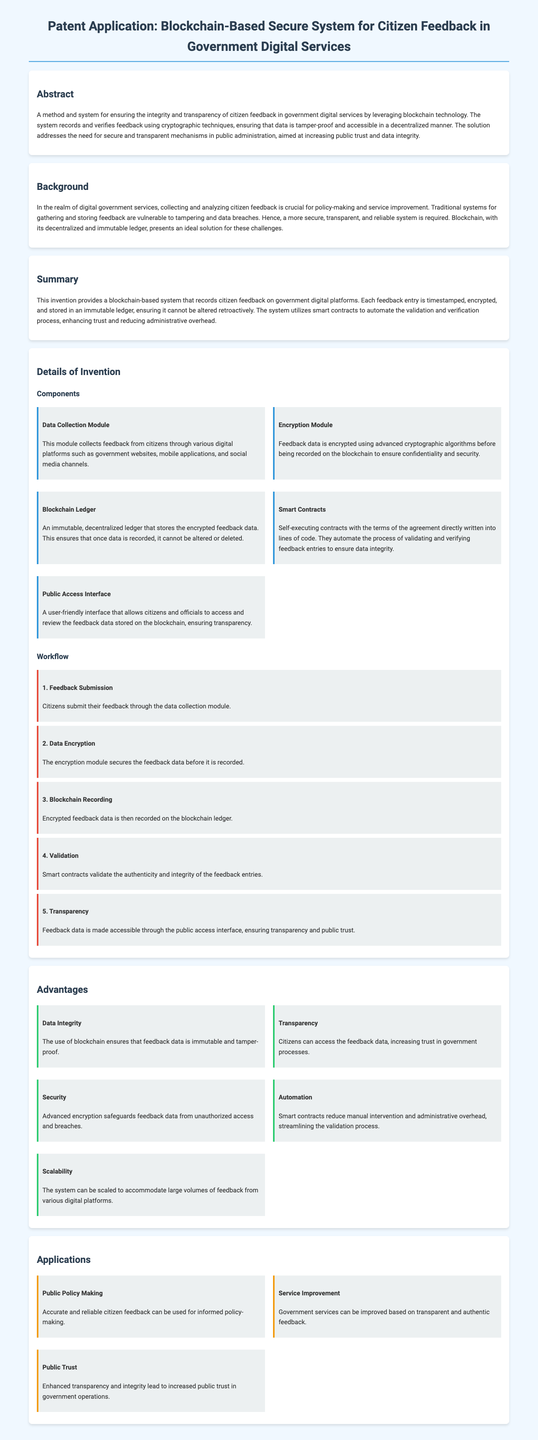What is the primary technology used in the system? The document states that the system leverages blockchain technology for integrity and transparency.
Answer: Blockchain technology What is ensured by the encryption module? The encryption module secures the feedback data before it is recorded, ensuring confidentiality and security.
Answer: Confidentiality and security What is the first step in the workflow? The first step in the workflow is feedback submission through the data collection module.
Answer: Feedback Submission How does the system enhance trust? The system enhances trust by automating validation and verification through smart contracts, ensuring data integrity.
Answer: Smart contracts What type of feedback does the system collect? The system collects citizen feedback from various digital platforms such as government websites and mobile applications.
Answer: Citizen feedback What is one major advantage of using blockchain? One major advantage is data integrity, as the use of blockchain ensures that feedback data is immutable and tamper-proof.
Answer: Data Integrity What is a key application of the system? A key application of the system is public policy making, which utilizes accurate and reliable citizen feedback.
Answer: Public Policy Making How many components are listed in the details of the invention? Five components are listed in the details of the invention.
Answer: Five components 